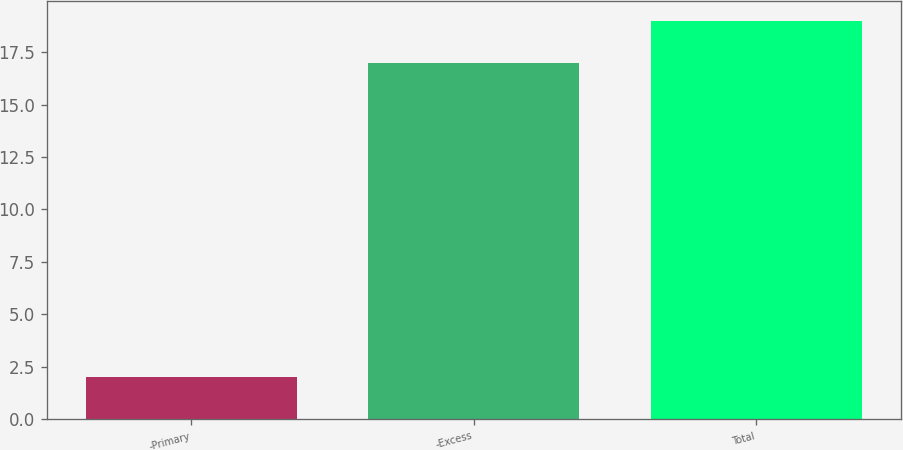Convert chart to OTSL. <chart><loc_0><loc_0><loc_500><loc_500><bar_chart><fcel>-Primary<fcel>-Excess<fcel>Total<nl><fcel>2<fcel>17<fcel>19<nl></chart> 